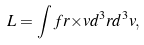Convert formula to latex. <formula><loc_0><loc_0><loc_500><loc_500>L = \int f { r } { \times } { v } d ^ { 3 } { r } d ^ { 3 } { v } ,</formula> 